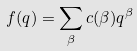<formula> <loc_0><loc_0><loc_500><loc_500>f ( q ) = \sum _ { \beta } c ( \beta ) q ^ { \beta }</formula> 